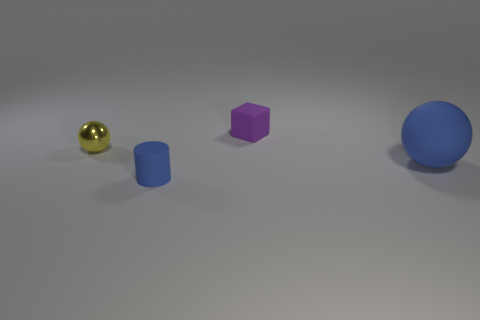There is a blue thing on the right side of the object that is in front of the large rubber sphere; how big is it?
Offer a terse response. Large. Are there any other things that are the same size as the purple rubber cube?
Your answer should be very brief. Yes. There is a big blue thing that is the same shape as the tiny yellow metallic object; what is its material?
Provide a succinct answer. Rubber. Do the blue matte thing on the left side of the purple matte thing and the object that is behind the yellow metal object have the same shape?
Your answer should be compact. No. Are there more metallic objects than small brown objects?
Ensure brevity in your answer.  Yes. How big is the cube?
Provide a succinct answer. Small. What number of other objects are there of the same color as the tiny metal thing?
Keep it short and to the point. 0. Is the tiny thing that is in front of the big blue sphere made of the same material as the yellow object?
Offer a very short reply. No. Are there fewer metallic spheres that are on the left side of the small yellow thing than tiny things in front of the blue ball?
Offer a terse response. Yes. How many other things are the same material as the block?
Keep it short and to the point. 2. 